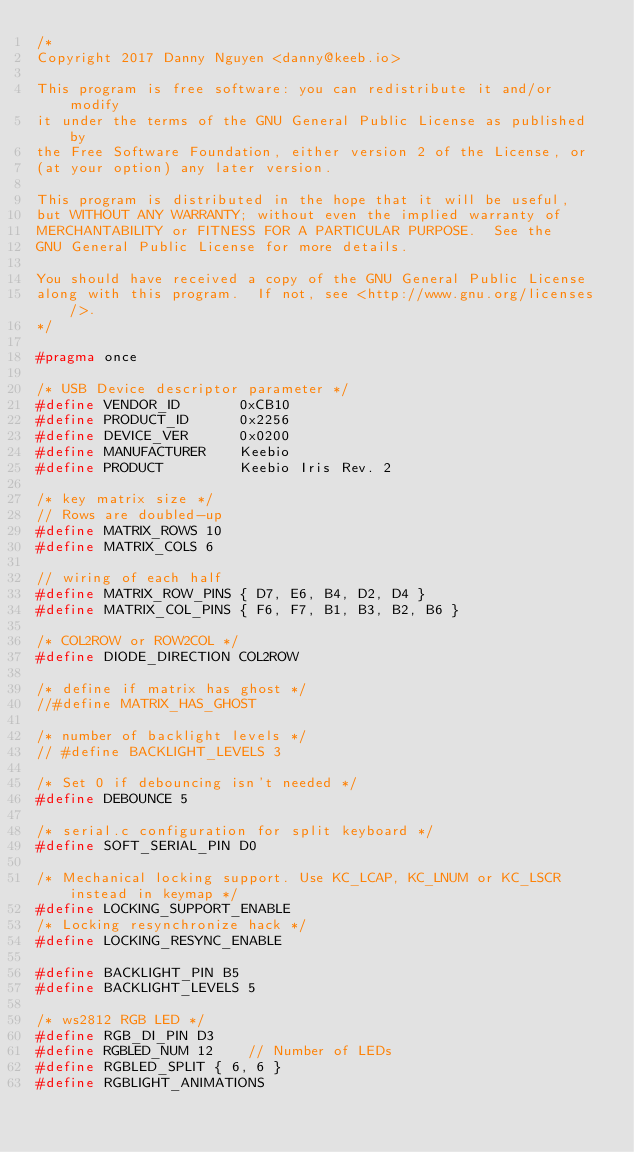<code> <loc_0><loc_0><loc_500><loc_500><_C_>/*
Copyright 2017 Danny Nguyen <danny@keeb.io>

This program is free software: you can redistribute it and/or modify
it under the terms of the GNU General Public License as published by
the Free Software Foundation, either version 2 of the License, or
(at your option) any later version.

This program is distributed in the hope that it will be useful,
but WITHOUT ANY WARRANTY; without even the implied warranty of
MERCHANTABILITY or FITNESS FOR A PARTICULAR PURPOSE.  See the
GNU General Public License for more details.

You should have received a copy of the GNU General Public License
along with this program.  If not, see <http://www.gnu.org/licenses/>.
*/

#pragma once

/* USB Device descriptor parameter */
#define VENDOR_ID       0xCB10
#define PRODUCT_ID      0x2256
#define DEVICE_VER      0x0200
#define MANUFACTURER    Keebio
#define PRODUCT         Keebio Iris Rev. 2

/* key matrix size */
// Rows are doubled-up
#define MATRIX_ROWS 10
#define MATRIX_COLS 6

// wiring of each half
#define MATRIX_ROW_PINS { D7, E6, B4, D2, D4 }
#define MATRIX_COL_PINS { F6, F7, B1, B3, B2, B6 }

/* COL2ROW or ROW2COL */
#define DIODE_DIRECTION COL2ROW

/* define if matrix has ghost */
//#define MATRIX_HAS_GHOST

/* number of backlight levels */
// #define BACKLIGHT_LEVELS 3

/* Set 0 if debouncing isn't needed */
#define DEBOUNCE 5

/* serial.c configuration for split keyboard */
#define SOFT_SERIAL_PIN D0

/* Mechanical locking support. Use KC_LCAP, KC_LNUM or KC_LSCR instead in keymap */
#define LOCKING_SUPPORT_ENABLE
/* Locking resynchronize hack */
#define LOCKING_RESYNC_ENABLE

#define BACKLIGHT_PIN B5
#define BACKLIGHT_LEVELS 5

/* ws2812 RGB LED */
#define RGB_DI_PIN D3
#define RGBLED_NUM 12    // Number of LEDs
#define RGBLED_SPLIT { 6, 6 }
#define RGBLIGHT_ANIMATIONS
</code> 